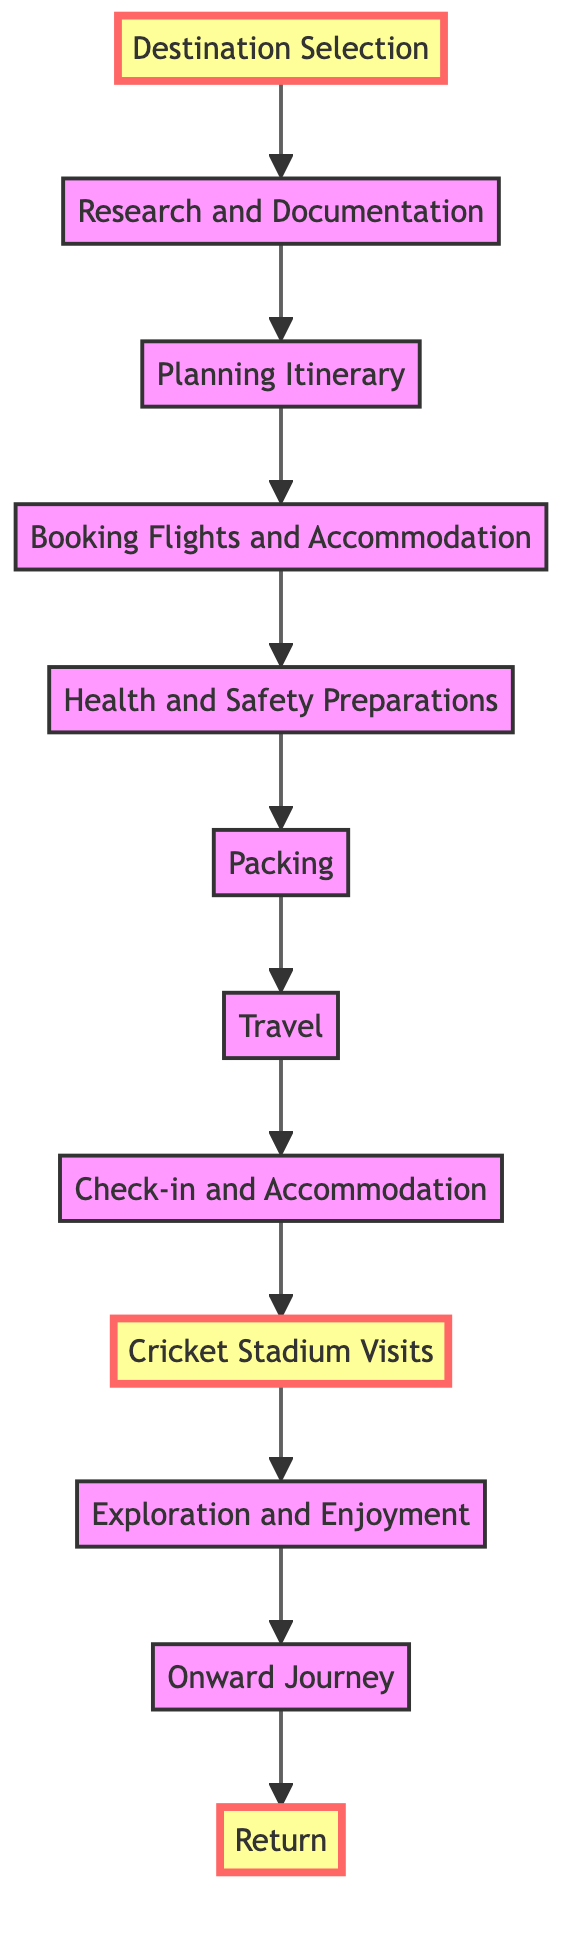What is the first step in the journey? The diagram indicates that the first step in the journey is "Destination Selection." It is the starting point of the entire planning process, as all subsequent steps depend on this initial choice.
Answer: Destination Selection How many steps are there in total? By counting the nodes from "Destination Selection" to "Return," there are a total of 12 steps in the flowchart. This includes all actions taken from planning to returning home.
Answer: 12 What step comes immediately after "Booking Flights and Accommodation"? The step that follows "Booking Flights and Accommodation" is "Health and Safety Preparations." This indicates that once flights and accommodations are secured, preparations for health and safety follow next in the journey.
Answer: Health and Safety Preparations Which step is focused on exploring the local cricket culture? The step that emphasizes exploring local cricket culture is "Cricket Stadium Visits." This highlights the traveler's interest in visiting significant cricket venues during the international travel adventure.
Answer: Cricket Stadium Visits What is the last step in the journey? The final step in the journey, according to the flowchart, is "Return." This signifies the completion of the travel adventure and returning back to home in Hawaii.
Answer: Return Which steps are highlighted in the diagram? The steps highlighted in the diagram are "Destination Selection," "Cricket Stadium Visits," and "Return." Highlighting these steps suggests their particular importance in the journey.
Answer: Destination Selection, Cricket Stadium Visits, Return What is the step before "Onward Journey"? The step that occurs right before "Onward Journey" is "Exploration and Enjoyment." This indicates that the traveler enjoys activities and experiences just prior to heading back home.
Answer: Exploration and Enjoyment How does the flow of the diagram progress? The flow of the diagram progresses from the bottom to the top, illustrating the stages of planning and executing an international travel adventure, culminating in returning home.
Answer: Bottom to top 